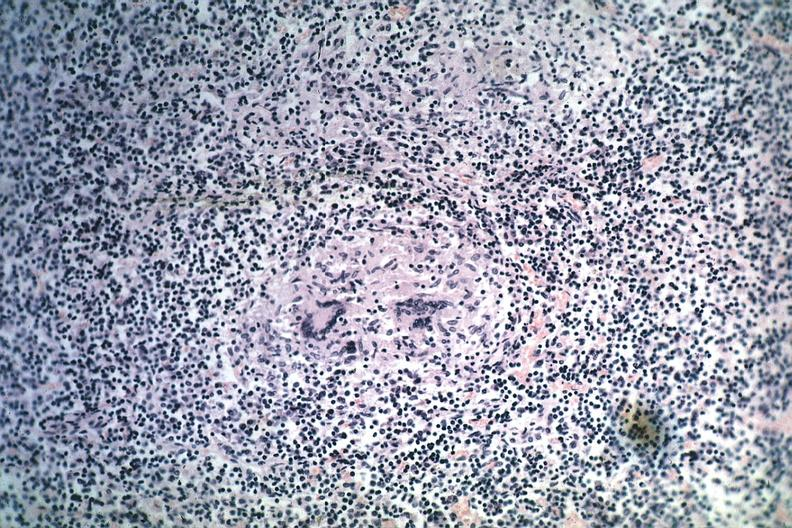what is present?
Answer the question using a single word or phrase. Tuberculosis 